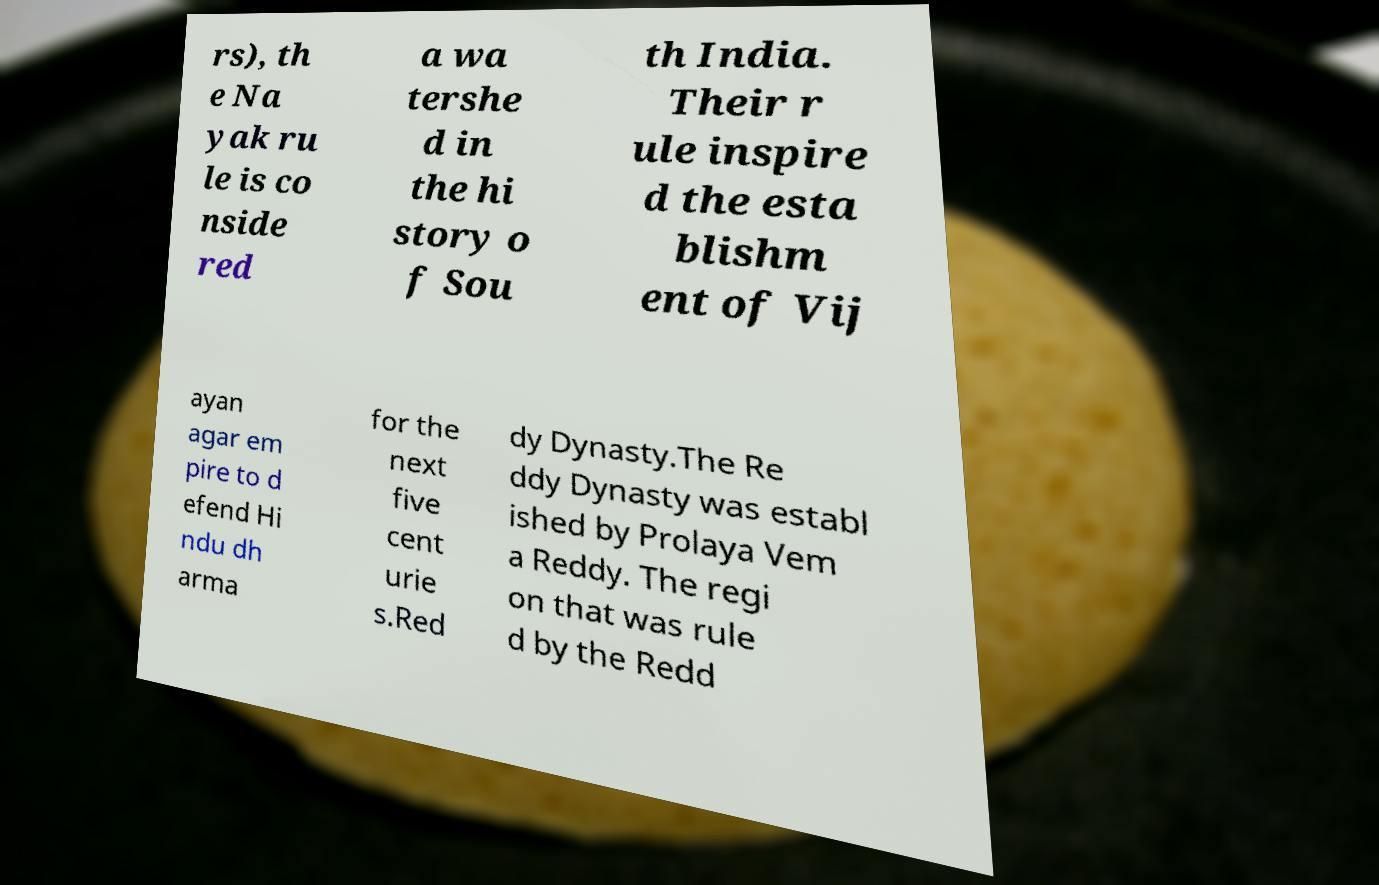Can you accurately transcribe the text from the provided image for me? rs), th e Na yak ru le is co nside red a wa tershe d in the hi story o f Sou th India. Their r ule inspire d the esta blishm ent of Vij ayan agar em pire to d efend Hi ndu dh arma for the next five cent urie s.Red dy Dynasty.The Re ddy Dynasty was establ ished by Prolaya Vem a Reddy. The regi on that was rule d by the Redd 